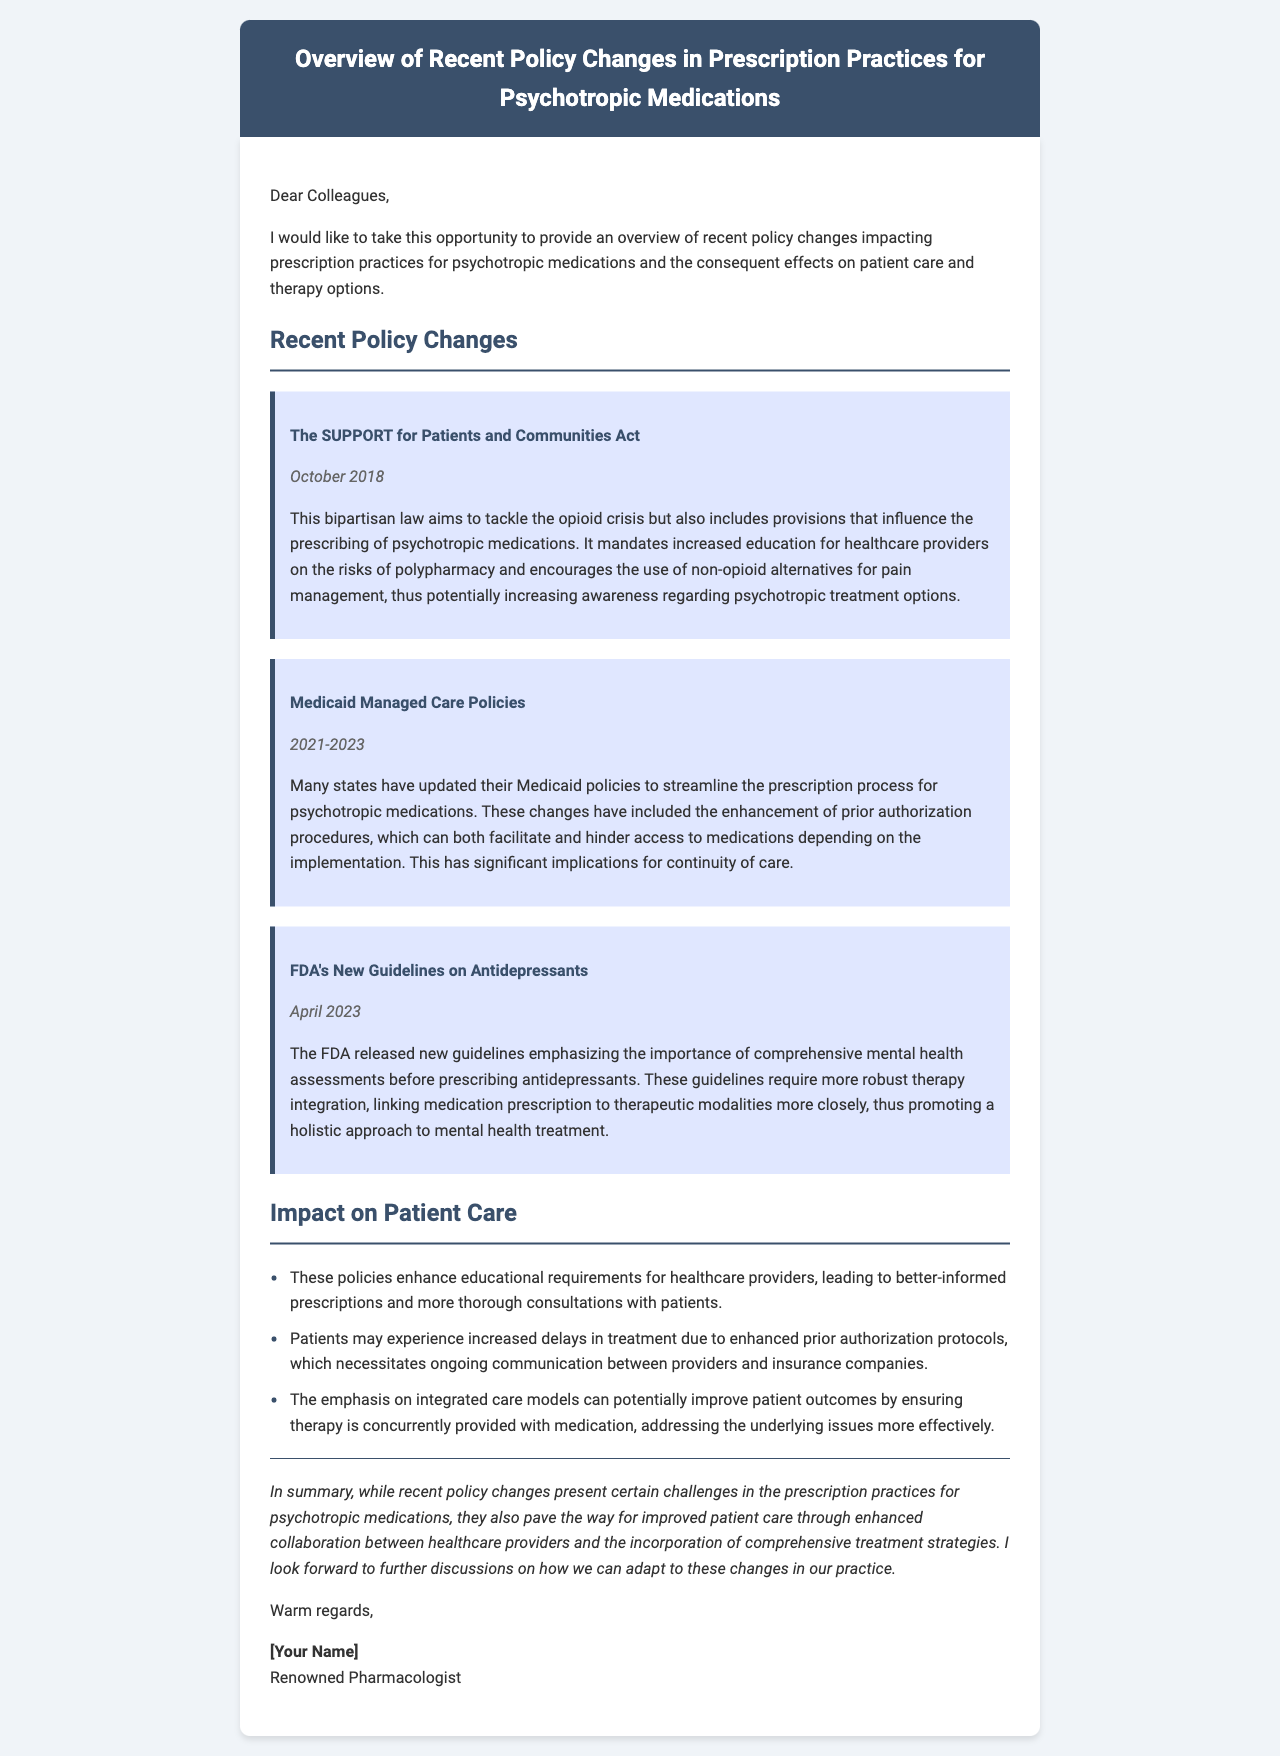What is the title of the law mentioned in the policy changes? The title of the law is provided as a specific policy change in the document's body.
Answer: SUPPORT for Patients and Communities Act What year was the SUPPORT for Patients and Communities Act enacted? The document states the specific date when the law was enacted.
Answer: October 2018 Which policy emphasizes mental health assessments before prescribing? The document identifies the specific guideline from the FDA discussing this requirement.
Answer: FDA's New Guidelines on Antidepressants What are the two main effects of enhanced prior authorization procedures? The document notes both positive and negative implications regarding continuity of care due to these procedures.
Answer: Facilitate and hinder access What is one potential benefit of integrated care models highlighted in the document? The document discusses the impact of integrated care on patient outcomes as a form of improved care.
Answer: Improve patient outcomes How does the document conclude the overview of policy changes? The conclusion summarizes the overall impact of the policy changes on patient care and collaboration among providers.
Answer: Challenges and improved patient care 